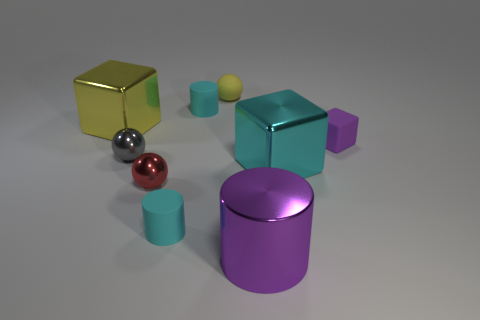Add 1 big yellow metallic objects. How many objects exist? 10 Subtract all cubes. How many objects are left? 6 Add 8 small cubes. How many small cubes are left? 9 Add 9 tiny purple blocks. How many tiny purple blocks exist? 10 Subtract 0 brown blocks. How many objects are left? 9 Subtract all big green rubber cubes. Subtract all cyan cylinders. How many objects are left? 7 